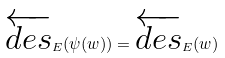Convert formula to latex. <formula><loc_0><loc_0><loc_500><loc_500>\overleftarrow { d e s } _ { E } ( \psi ( w ) ) = \overleftarrow { d e s } _ { E } ( w )</formula> 